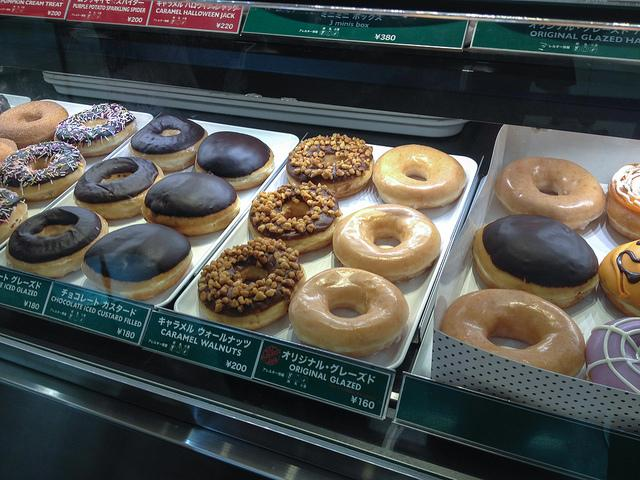Where can you buy these donuts?

Choices:
A) japan
B) south korea
C) china
D) singapore japan 